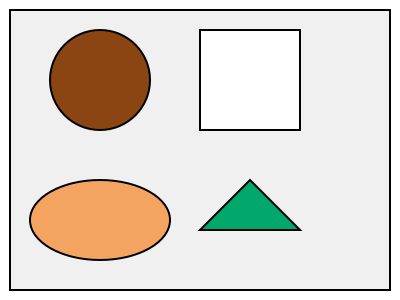Which of the shapes in the image represents a material commonly used in compostable packaging that is derived from plant-based sources and biodegrades quickly? To answer this question, let's analyze each shape and its potential representation:

1. Circle (brown): This could represent a coconut-based material, which is sometimes used in eco-friendly packaging but is not as common or quick to biodegrade.

2. Square (white): This might represent recycled paper or cardboard, which is biodegradable but not always considered compostable in all settings.

3. Triangle (green): This shape and color likely represent a plant-based bioplastic, such as PLA (Polylactic Acid). PLA is derived from renewable resources like corn starch or sugarcane and is known for its quick biodegradation in industrial composting facilities.

4. Ellipse (tan): This could represent a material made from wheat straw or other agricultural byproducts, which are compostable but not as widely used in packaging as bioplastics.

Among these options, the triangle (green) best represents a material commonly used in compostable packaging that is derived from plant-based sources and biodegrades quickly. PLA is widely used in sustainable packaging solutions due to its versatility, renewable source, and compostability.
Answer: Triangle (green) 